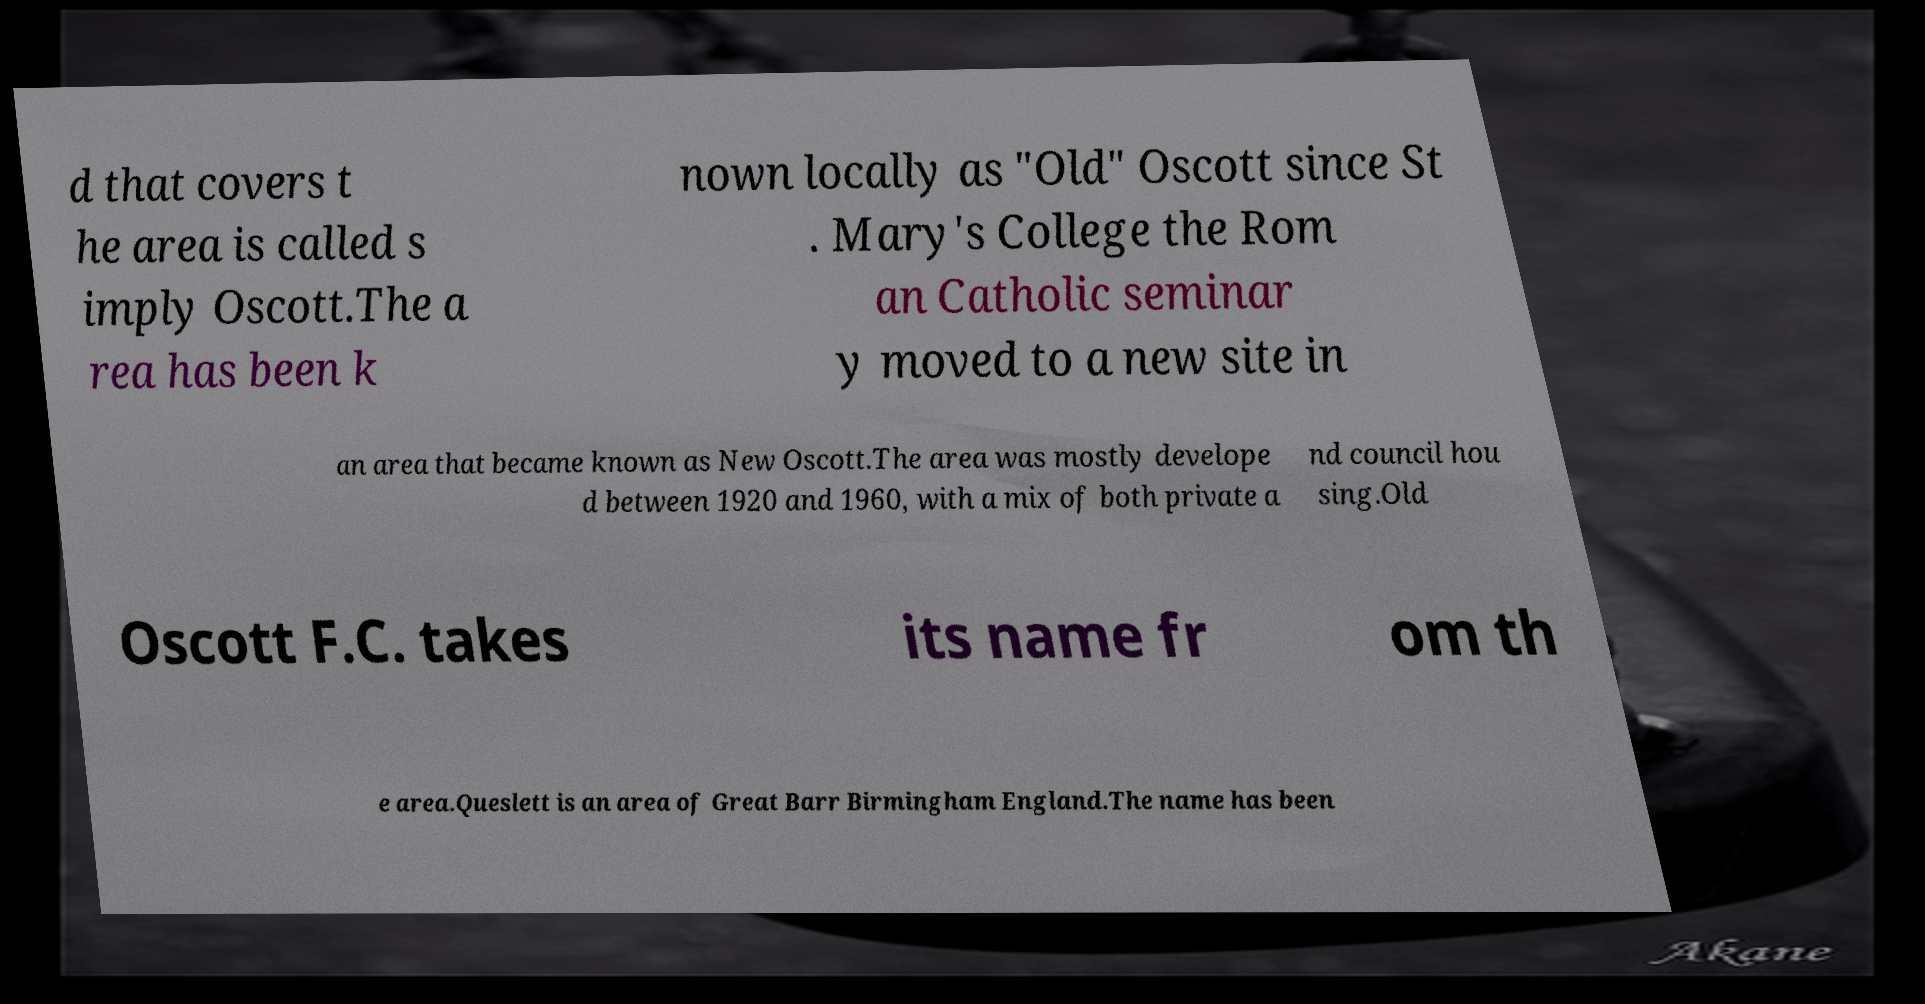Could you extract and type out the text from this image? d that covers t he area is called s imply Oscott.The a rea has been k nown locally as "Old" Oscott since St . Mary's College the Rom an Catholic seminar y moved to a new site in an area that became known as New Oscott.The area was mostly develope d between 1920 and 1960, with a mix of both private a nd council hou sing.Old Oscott F.C. takes its name fr om th e area.Queslett is an area of Great Barr Birmingham England.The name has been 